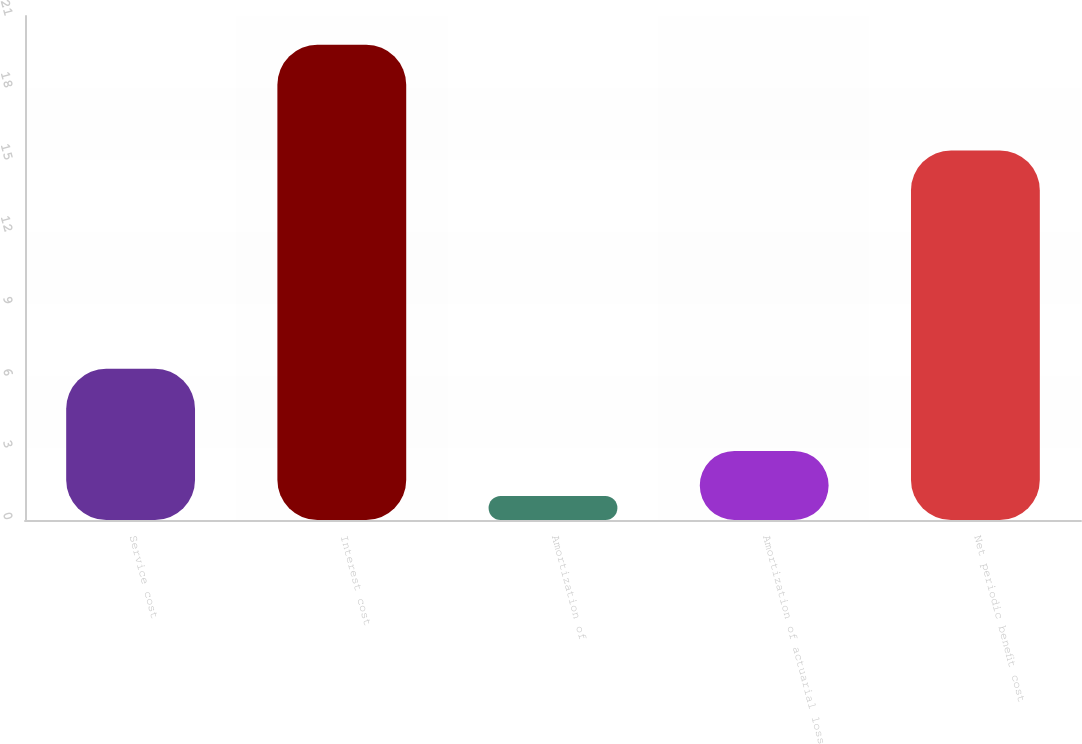Convert chart. <chart><loc_0><loc_0><loc_500><loc_500><bar_chart><fcel>Service cost<fcel>Interest cost<fcel>Amortization of<fcel>Amortization of actuarial loss<fcel>Net periodic benefit cost<nl><fcel>6.3<fcel>19.8<fcel>1<fcel>2.88<fcel>15.4<nl></chart> 